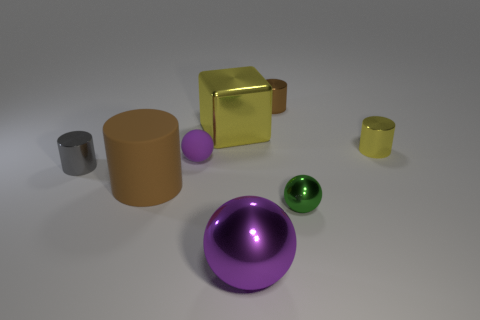Subtract all blue cylinders. How many purple balls are left? 2 Subtract all gray cylinders. How many cylinders are left? 3 Subtract 2 cylinders. How many cylinders are left? 2 Subtract all purple spheres. How many spheres are left? 1 Add 1 large blocks. How many objects exist? 9 Subtract all green cylinders. Subtract all purple balls. How many cylinders are left? 4 Subtract all cubes. How many objects are left? 7 Add 8 purple balls. How many purple balls are left? 10 Add 5 brown shiny things. How many brown shiny things exist? 6 Subtract 0 blue cubes. How many objects are left? 8 